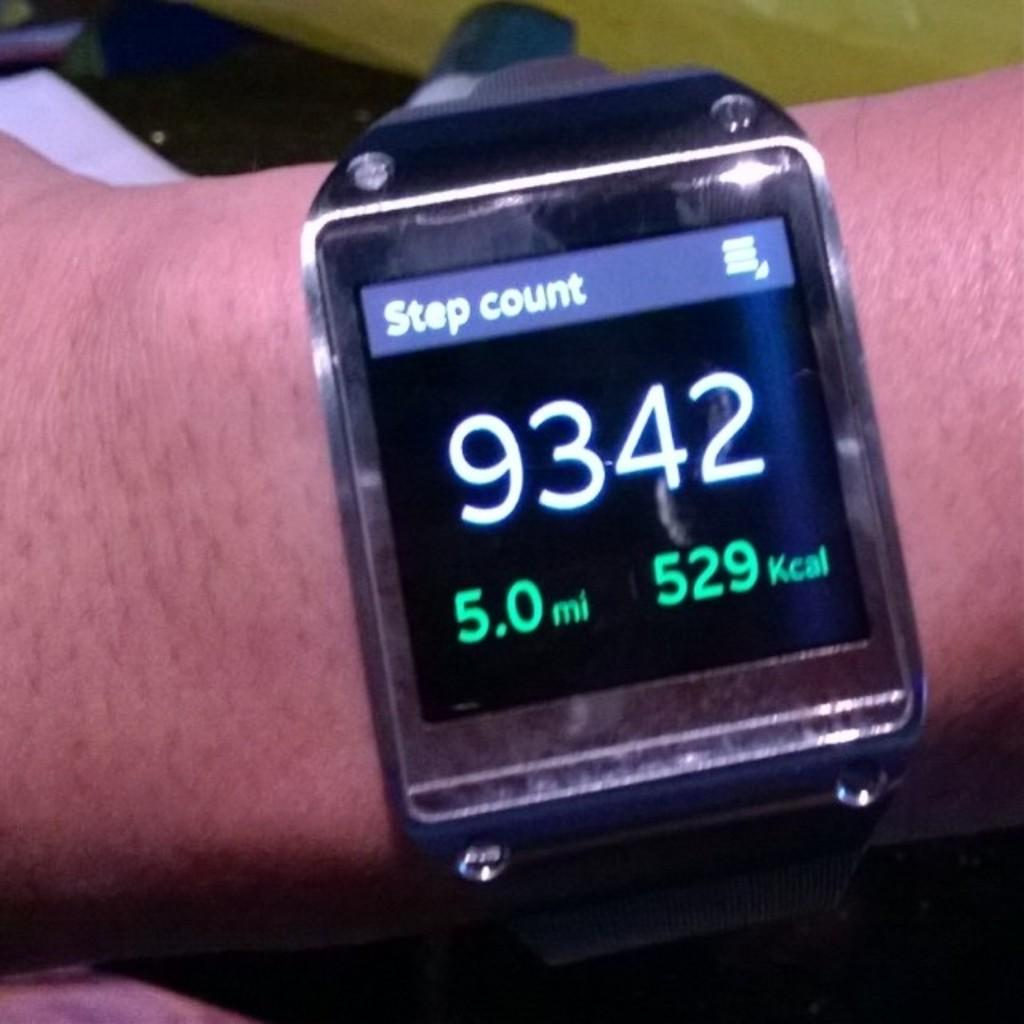<image>
Offer a succinct explanation of the picture presented. Face of a watch which tells the Step Count. 